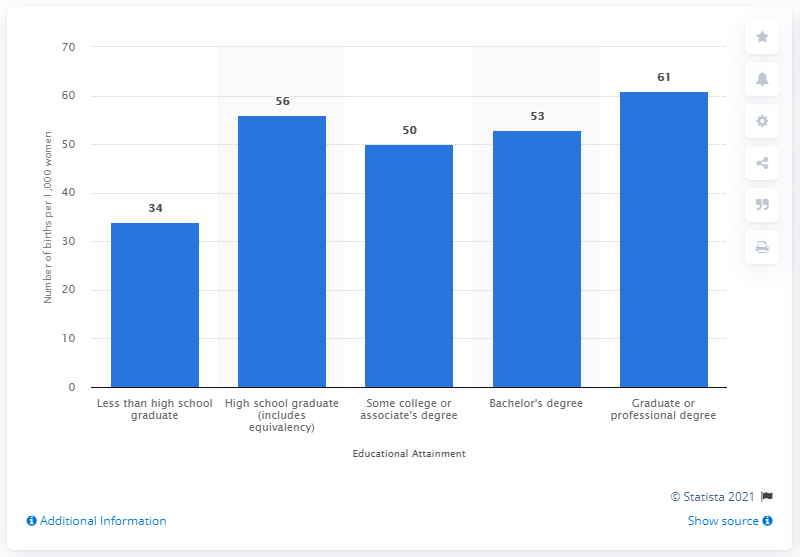List a handful of essential elements in this visual. In 2019, there were approximately 53 children born per 1,000 women with a Bachelor's degree. The average birth rate between individuals with a bachelor's degree and those with a high school diploma is 54.5. In 2019, the birthrate of Bachelor degree holders in the United States was 53%. In the United States, approximately 61 children were born per 1,000 women with a graduate or professional degree in 2018. 